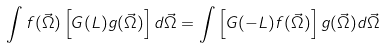Convert formula to latex. <formula><loc_0><loc_0><loc_500><loc_500>\int { f ( \vec { \Omega } ) \left [ G ( L ) g ( \vec { \Omega } ) \right ] d \vec { \Omega } } = \int { \left [ G ( - L ) f ( \vec { \Omega } ) \right ] g ( \vec { \Omega } ) d \vec { \Omega } }</formula> 